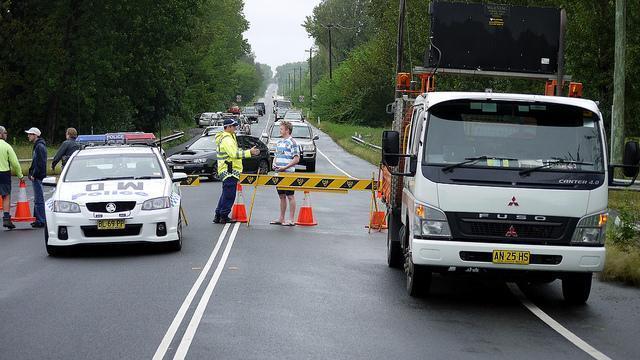How many vehicles are in the photo?
Give a very brief answer. 10. How many cones are there?
Give a very brief answer. 4. How many cars are there?
Give a very brief answer. 2. How many toilets are there?
Give a very brief answer. 0. 